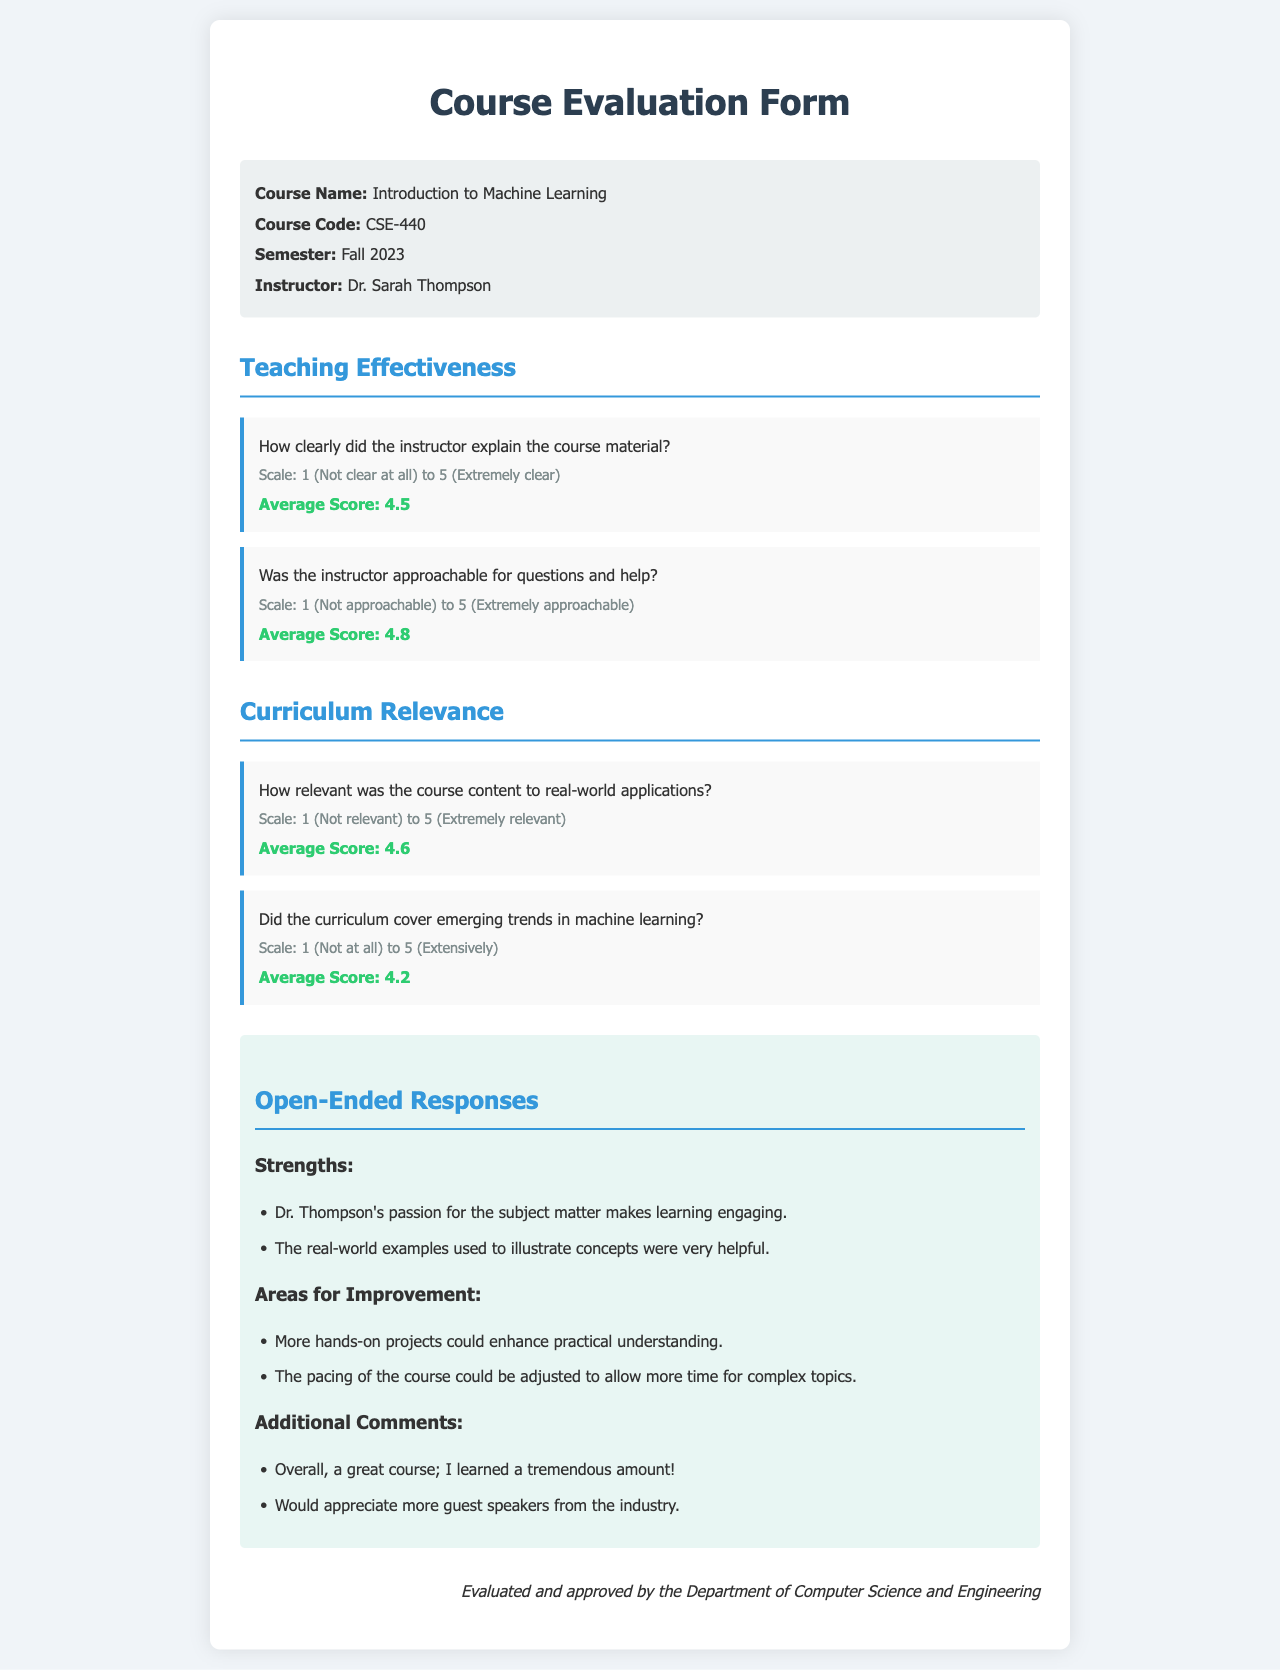What is the course name? The course name is specified in the course details section of the document.
Answer: Introduction to Machine Learning Who is the instructor? The instructor's name is mentioned in the course details section.
Answer: Dr. Sarah Thompson What is the average score for the instructor's approachability? This score is provided under the teaching effectiveness section, reflecting students' perceptions.
Answer: 4.8 How relevant was the course content to real-world applications? The relevance of the course content is indicated by a specific score in the curriculum relevance section.
Answer: 4.6 What is one strength noted by students in the open-ended responses? Student feedback in the strengths section highlights specific positive aspects of the course.
Answer: Passion for the subject matter What could enhance practical understanding according to the feedback? Suggestions for improvement are listed in the areas for improvement section of open-ended responses.
Answer: More hands-on projects What is an additional comment made by students? Additional comments reflect overall sentiment and suggestions, noted in a specific section of the document.
Answer: Overall, a great course; I learned a tremendous amount! Did the curriculum cover emerging trends in machine learning? This question can be answered by referring to the specific score provided in the curriculum relevance section.
Answer: 4.2 What semester was this course offered? The semester is mentioned in the course details section of the form.
Answer: Fall 2023 